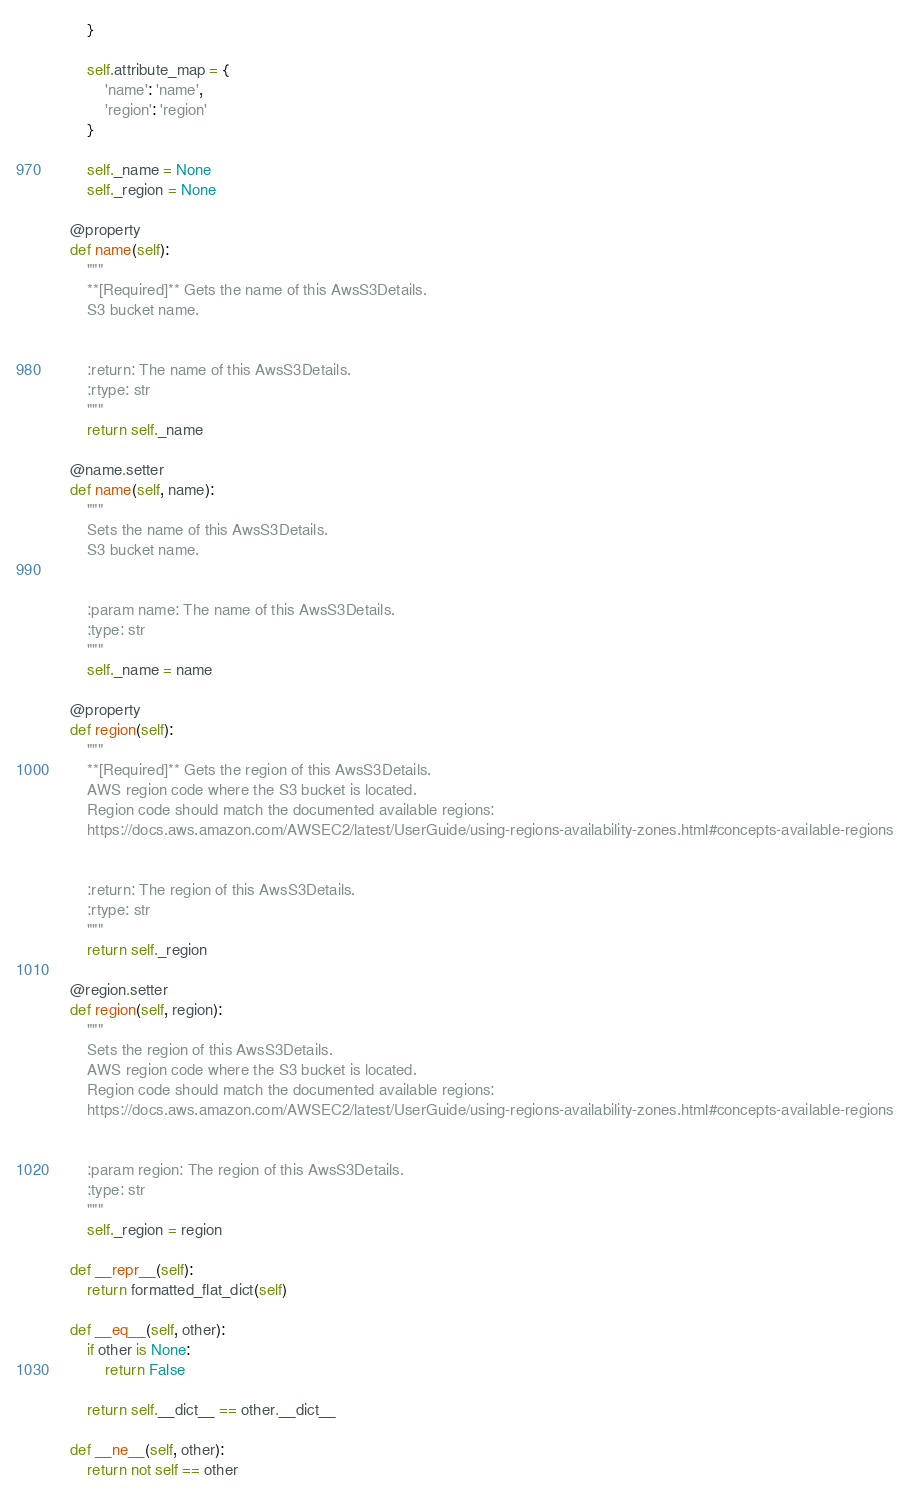<code> <loc_0><loc_0><loc_500><loc_500><_Python_>        }

        self.attribute_map = {
            'name': 'name',
            'region': 'region'
        }

        self._name = None
        self._region = None

    @property
    def name(self):
        """
        **[Required]** Gets the name of this AwsS3Details.
        S3 bucket name.


        :return: The name of this AwsS3Details.
        :rtype: str
        """
        return self._name

    @name.setter
    def name(self, name):
        """
        Sets the name of this AwsS3Details.
        S3 bucket name.


        :param name: The name of this AwsS3Details.
        :type: str
        """
        self._name = name

    @property
    def region(self):
        """
        **[Required]** Gets the region of this AwsS3Details.
        AWS region code where the S3 bucket is located.
        Region code should match the documented available regions:
        https://docs.aws.amazon.com/AWSEC2/latest/UserGuide/using-regions-availability-zones.html#concepts-available-regions


        :return: The region of this AwsS3Details.
        :rtype: str
        """
        return self._region

    @region.setter
    def region(self, region):
        """
        Sets the region of this AwsS3Details.
        AWS region code where the S3 bucket is located.
        Region code should match the documented available regions:
        https://docs.aws.amazon.com/AWSEC2/latest/UserGuide/using-regions-availability-zones.html#concepts-available-regions


        :param region: The region of this AwsS3Details.
        :type: str
        """
        self._region = region

    def __repr__(self):
        return formatted_flat_dict(self)

    def __eq__(self, other):
        if other is None:
            return False

        return self.__dict__ == other.__dict__

    def __ne__(self, other):
        return not self == other
</code> 